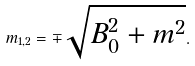Convert formula to latex. <formula><loc_0><loc_0><loc_500><loc_500>m _ { 1 , 2 } = \mp \sqrt { B _ { 0 } ^ { 2 } + m ^ { 2 } } .</formula> 